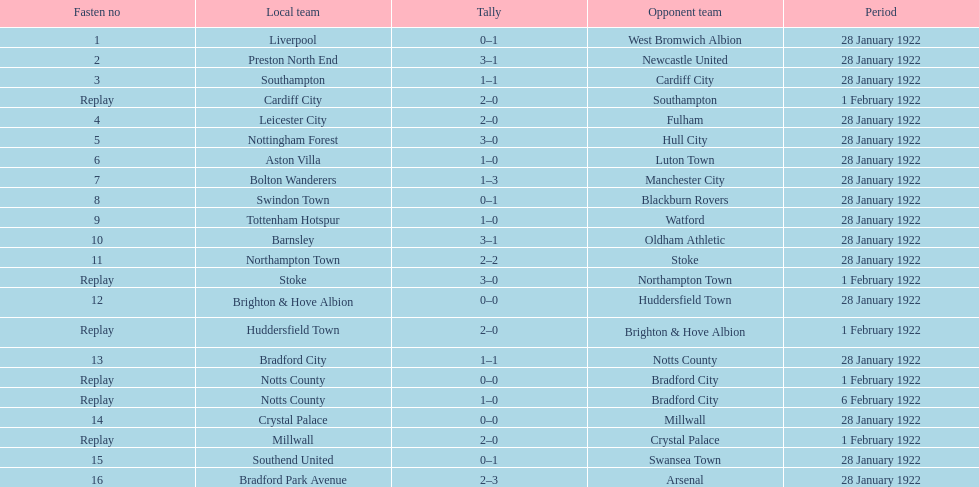How many games had four total points or more scored? 5. 